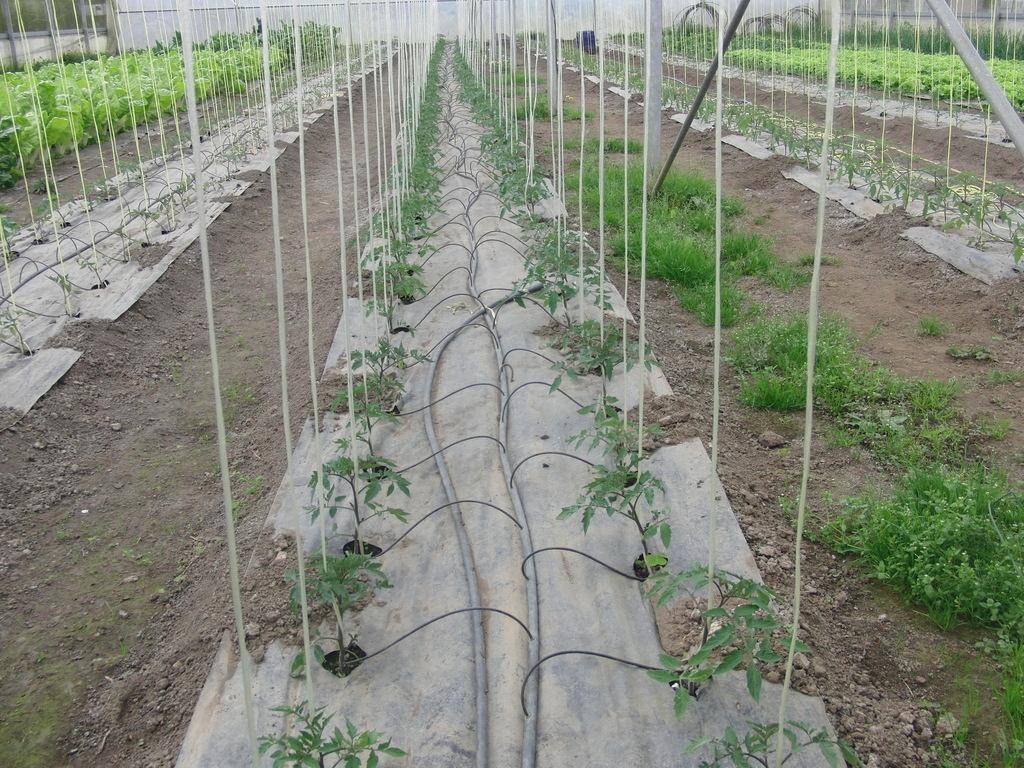What type of living organisms can be seen in the image? Plants are visible in the image. What is visible at the bottom of the image? There is ground visible at the bottom of the image. What can be seen in the background of the image? There is a wall in the background of the image. What type of attraction can be seen in the image? There is no attraction present in the image; it features plants, ground, and a wall. Can you tell me how many corn plants are visible in the image? There is no corn plant present in the image. 